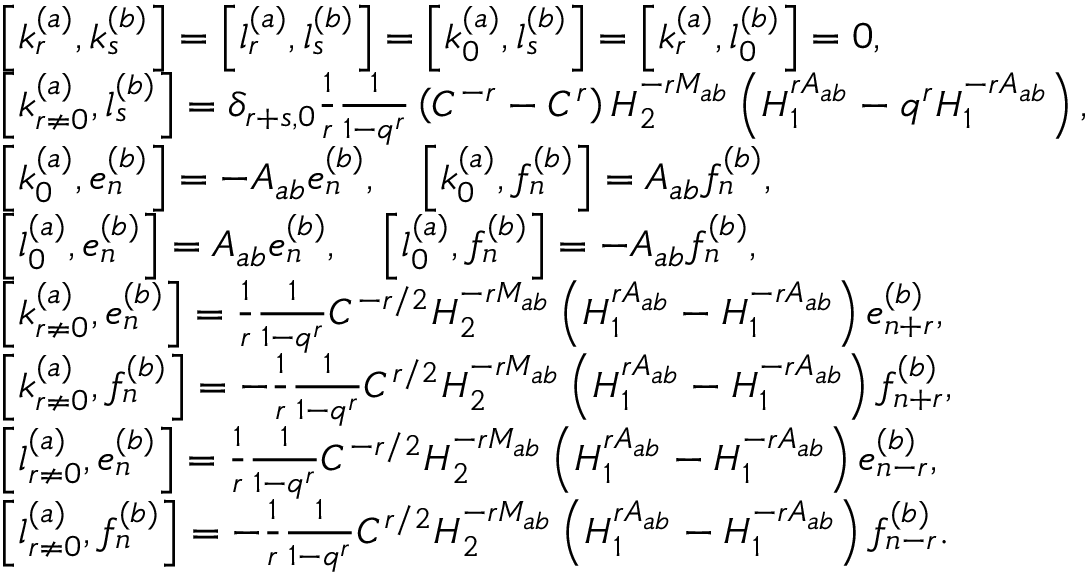Convert formula to latex. <formula><loc_0><loc_0><loc_500><loc_500>\begin{array} { r l } & { \left [ k _ { r } ^ { ( a ) } , k _ { s } ^ { ( b ) } \right ] = \left [ l _ { r } ^ { ( a ) } , l _ { s } ^ { ( b ) } \right ] = \left [ k _ { 0 } ^ { ( a ) } , l _ { s } ^ { ( b ) } \right ] = \left [ k _ { r } ^ { ( a ) } , l _ { 0 } ^ { ( b ) } \right ] = 0 , } \\ & { \left [ k _ { r \neq 0 } ^ { ( a ) } , l _ { s } ^ { ( b ) } \right ] = \delta _ { r + s , 0 } \frac { 1 } { r } \frac { 1 } { 1 - q ^ { r } } \left ( C ^ { - r } - C ^ { r } \right ) H _ { 2 } ^ { - r M _ { a b } } \left ( H _ { 1 } ^ { r A _ { a b } } - q ^ { r } H _ { 1 } ^ { - r A _ { a b } } \right ) , } \\ & { \left [ k _ { 0 } ^ { ( a ) } , e _ { n } ^ { ( b ) } \right ] = - A _ { a b } e _ { n } ^ { ( b ) } , \quad \left [ k _ { 0 } ^ { ( a ) } , f _ { n } ^ { ( b ) } \right ] = A _ { a b } f _ { n } ^ { ( b ) } , } \\ & { \left [ l _ { 0 } ^ { ( a ) } , e _ { n } ^ { ( b ) } \right ] = A _ { a b } e _ { n } ^ { ( b ) } , \quad \left [ l _ { 0 } ^ { ( a ) } , f _ { n } ^ { ( b ) } \right ] = - A _ { a b } f _ { n } ^ { ( b ) } , } \\ & { \left [ k _ { r \neq 0 } ^ { ( a ) } , e _ { n } ^ { ( b ) } \right ] = \frac { 1 } { r } \frac { 1 } { 1 - q ^ { r } } C ^ { - r / 2 } H _ { 2 } ^ { - r M _ { a b } } \left ( H _ { 1 } ^ { r A _ { a b } } - H _ { 1 } ^ { - r A _ { a b } } \right ) e _ { n + r } ^ { ( b ) } , } \\ & { \left [ k _ { r \neq 0 } ^ { ( a ) } , f _ { n } ^ { ( b ) } \right ] = - \frac { 1 } { r } \frac { 1 } { 1 - q ^ { r } } C ^ { r / 2 } H _ { 2 } ^ { - r M _ { a b } } \left ( H _ { 1 } ^ { r A _ { a b } } - H _ { 1 } ^ { - r A _ { a b } } \right ) f _ { n + r } ^ { ( b ) } , } \\ & { \left [ l _ { r \neq 0 } ^ { ( a ) } , e _ { n } ^ { ( b ) } \right ] = \frac { 1 } { r } \frac { 1 } { 1 - q ^ { r } } C ^ { - r / 2 } H _ { 2 } ^ { - r M _ { a b } } \left ( H _ { 1 } ^ { r A _ { a b } } - H _ { 1 } ^ { - r A _ { a b } } \right ) e _ { n - r } ^ { ( b ) } , } \\ & { \left [ l _ { r \neq 0 } ^ { ( a ) } , f _ { n } ^ { ( b ) } \right ] = - \frac { 1 } { r } \frac { 1 } { 1 - q ^ { r } } C ^ { r / 2 } H _ { 2 } ^ { - r M _ { a b } } \left ( H _ { 1 } ^ { r A _ { a b } } - H _ { 1 } ^ { - r A _ { a b } } \right ) f _ { n - r } ^ { ( b ) } . } \end{array}</formula> 